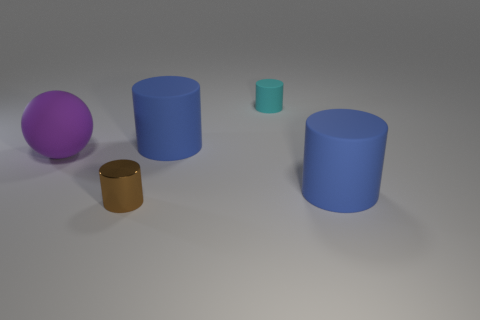Subtract all blue cylinders. Subtract all red blocks. How many cylinders are left? 2 Add 5 blue matte objects. How many objects exist? 10 Subtract all balls. How many objects are left? 4 Add 1 purple rubber objects. How many purple rubber objects exist? 2 Subtract 0 green blocks. How many objects are left? 5 Subtract all big yellow matte spheres. Subtract all big purple matte spheres. How many objects are left? 4 Add 3 big purple rubber things. How many big purple rubber things are left? 4 